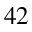<formula> <loc_0><loc_0><loc_500><loc_500>^ { 4 2 }</formula> 